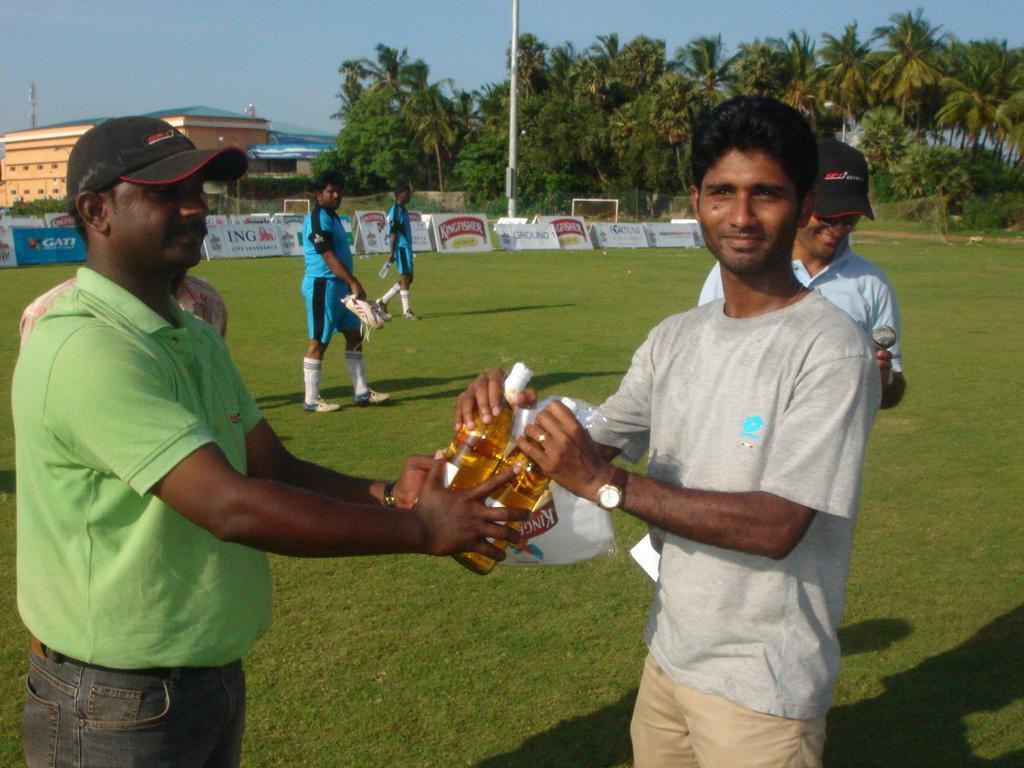Please provide a concise description of this image. These person are standing and these two persons are walking and holding objects. These two persons are holding bottles. On the background we can see trees,building,sky,pole,banners. This is grass. 